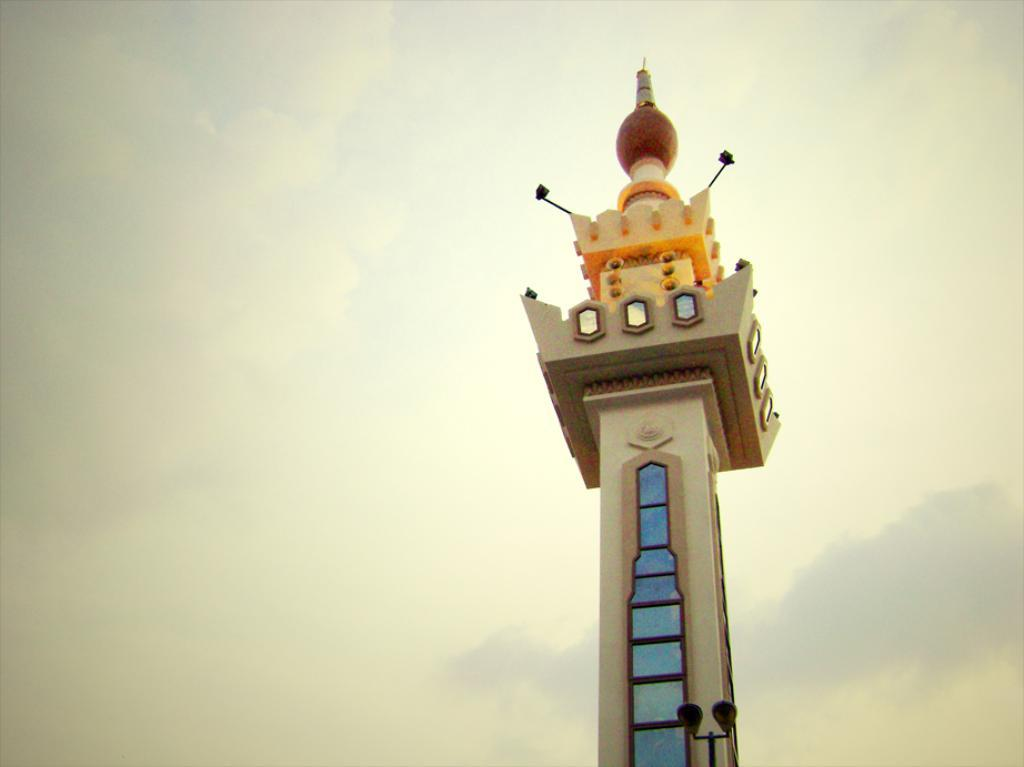What is the main structure in the image? There is a tower in the image. What decorative elements are present on the tower? The tower has paintings and lamps on it. What can be seen in the sky in the background of the image? There are clouds in the sky in the background of the image. Where is the box located in the image? There is no box present in the image. What type of power is being generated by the tower in the image? The image does not provide information about the tower generating any power. 